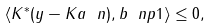Convert formula to latex. <formula><loc_0><loc_0><loc_500><loc_500>\langle K ^ { * } ( y - K a \ n ) , b \ n p 1 \rangle \leq 0 ,</formula> 